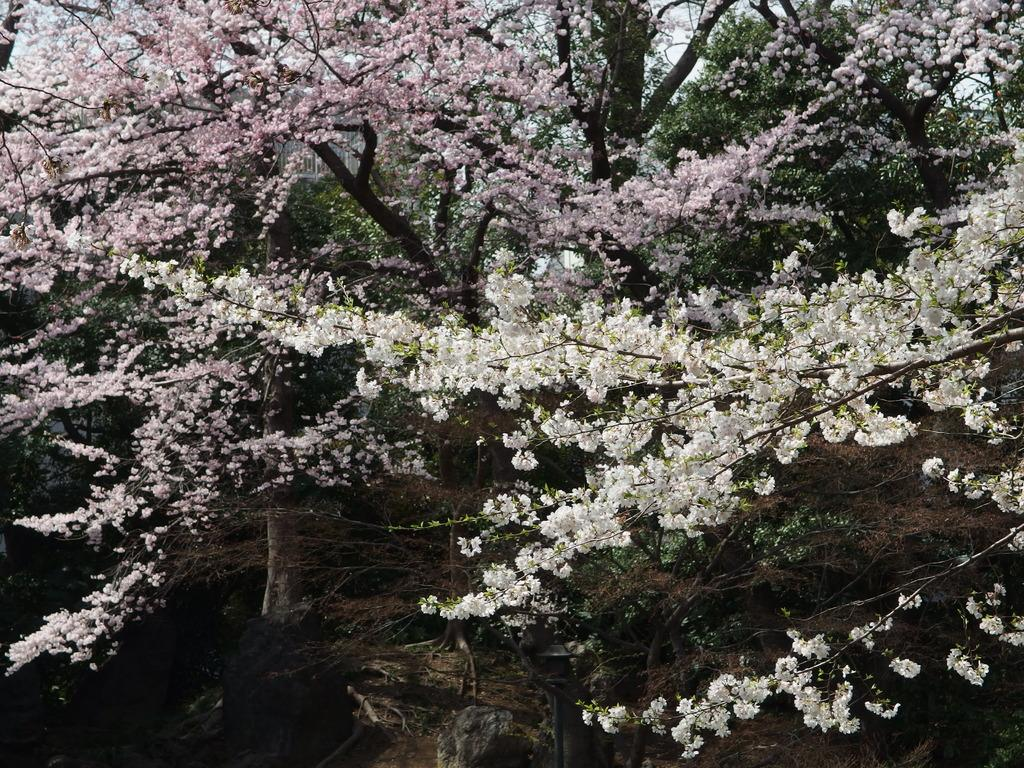What type of vegetation is visible in the image? There are trees in the image. What other natural elements can be seen in the image? There are flowers in the image. What colors are the flowers in the image? The flowers are in white and pink colors. What type of weather can be seen in the image? The image does not depict any weather conditions; it only shows trees and flowers. What season is depicted in the image? The image does not explicitly depict a specific season, as it only shows trees and flowers. 